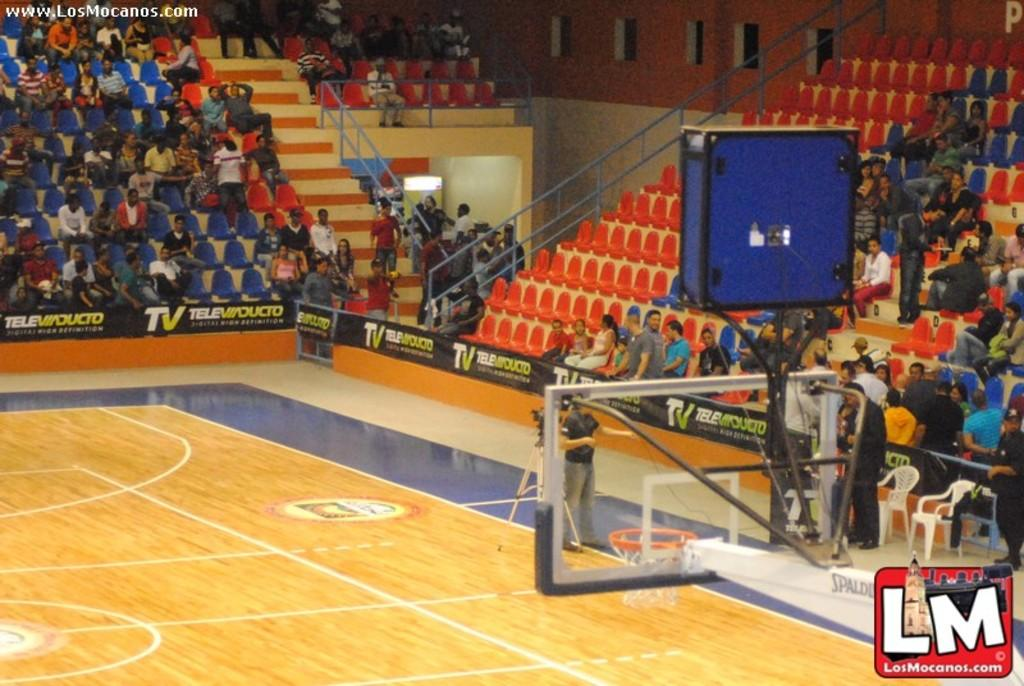<image>
Present a compact description of the photo's key features. A Los Mocanos logo can be seen with a basketball court in the background. 